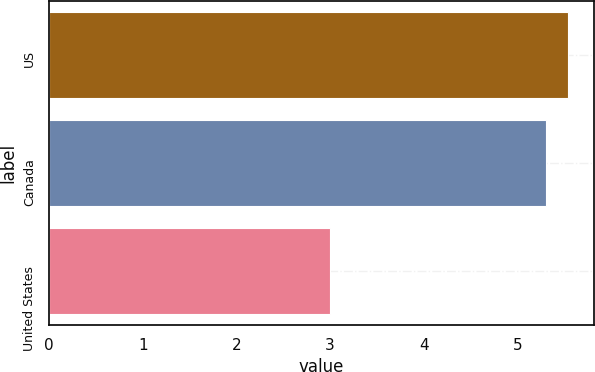Convert chart. <chart><loc_0><loc_0><loc_500><loc_500><bar_chart><fcel>US<fcel>Canada<fcel>United States<nl><fcel>5.54<fcel>5.3<fcel>3<nl></chart> 